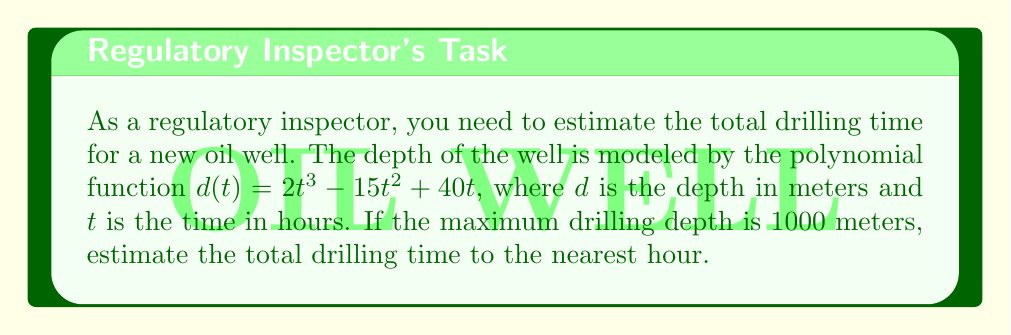Solve this math problem. To solve this problem, we need to follow these steps:

1) The drilling depth is given by the function $d(t) = 2t^3 - 15t^2 + 40t$.

2) We need to find the time $t$ when the depth $d(t)$ reaches 1000 meters. This means solving the equation:

   $2t^3 - 15t^2 + 40t = 1000$

3) This is a cubic equation and doesn't have a simple analytical solution. We can solve it numerically or graphically.

4) Let's define a new function $f(t) = 2t^3 - 15t^2 + 40t - 1000$. We need to find the root of this function.

5) Using a graphing calculator or computer software, we can plot this function and find where it crosses the x-axis.

6) Alternatively, we can use a numerical method like the Newton-Raphson method or bisection method to find the root.

7) Using such methods, we find that the function crosses the x-axis at approximately $t = 14.7$ hours.

8) Rounding to the nearest hour gives us 15 hours.
Answer: The estimated total drilling time is 15 hours. 